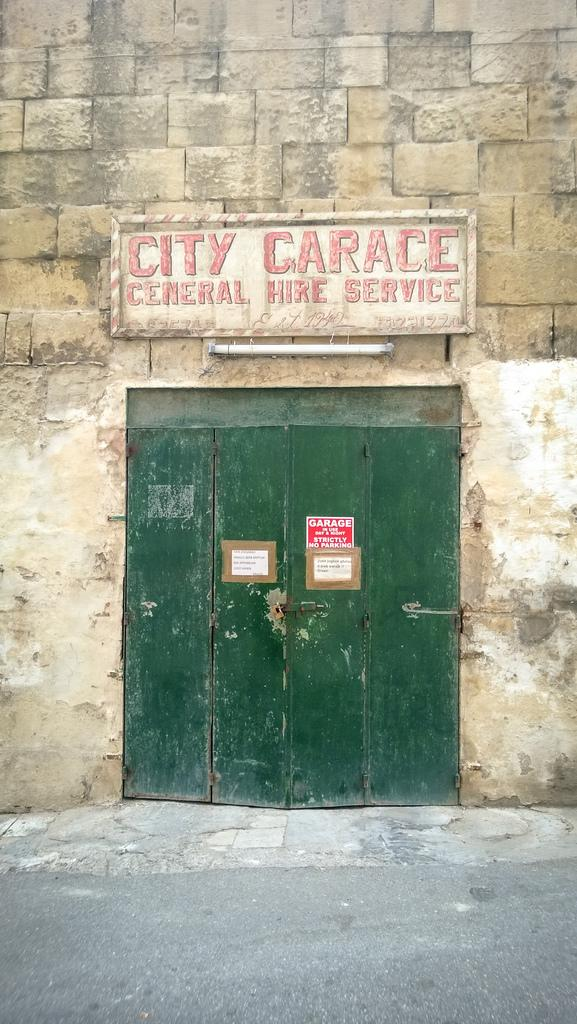What structure can be seen in the image? There is a gate in the image. What other object is present in the image? There is a board in the image. Is there any source of light visible in the image? Yes, there is a tube light in the image. What type of wall is visible in the image? There is a brick wall in the image. What is the setting of the image? The foreground of the image consists of a road. How many fish can be seen swimming in the jar in the image? There are no fish or jars present in the image. What message of love is conveyed by the image? The image does not convey any message of love; it features a gate, a board, a tube light, a brick wall, and a road. 